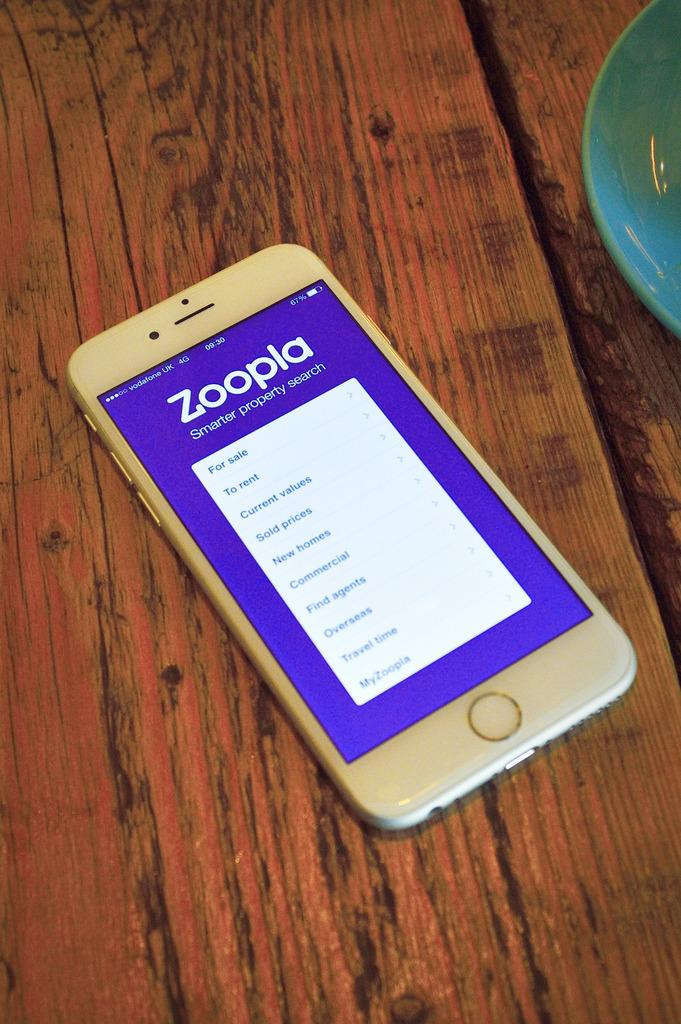<image>
Write a terse but informative summary of the picture. a cellphone on a wooden table with zoopia on the screen 